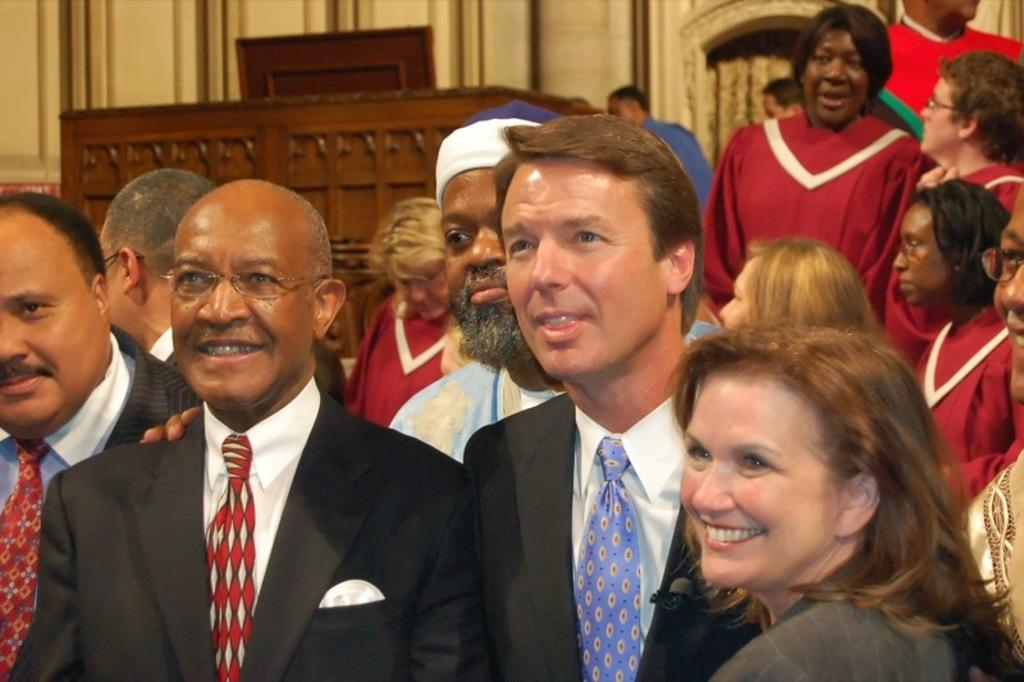Who or what can be seen in the image? There are people in the image. What is visible in the background of the image? There is a wall and a wooden object in the background of the image. How many rabbits are present in the image? There are no rabbits present in the image. What type of control is being used by the people in the image? There is no indication of any control being used by the people in the image. 